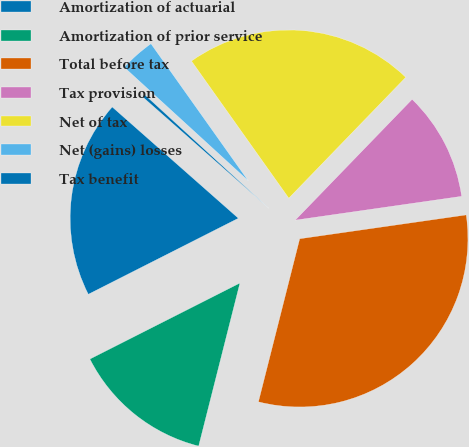<chart> <loc_0><loc_0><loc_500><loc_500><pie_chart><fcel>Amortization of actuarial<fcel>Amortization of prior service<fcel>Total before tax<fcel>Tax provision<fcel>Net of tax<fcel>Net (gains) losses<fcel>Tax benefit<nl><fcel>18.97%<fcel>13.59%<fcel>31.21%<fcel>10.5%<fcel>22.06%<fcel>3.38%<fcel>0.29%<nl></chart> 